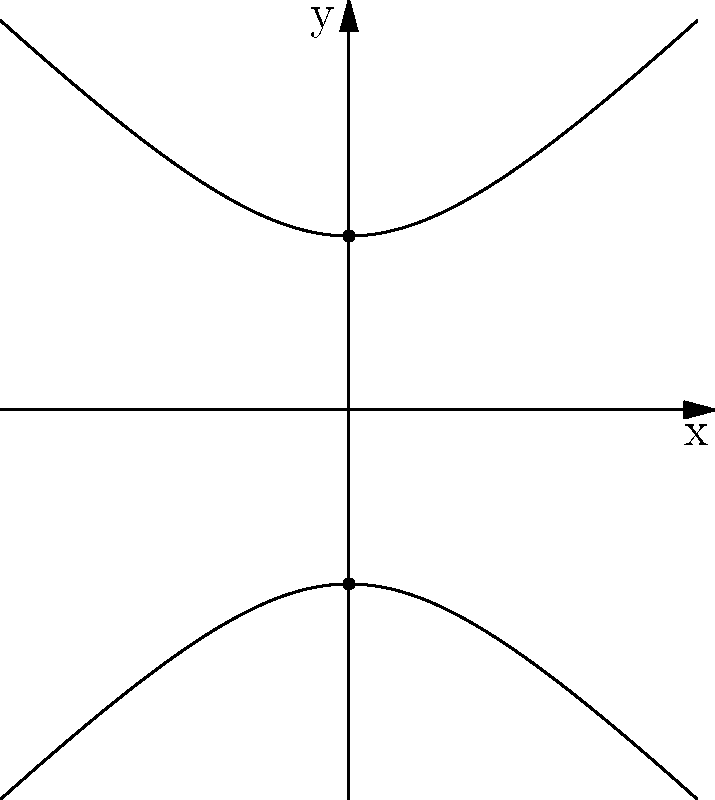As part of a stress management module in your online course, you're discussing how visualizing geometric shapes can aid in relaxation. Identify the type of conic section represented by the graph above and explain its significance in promoting calmness. To identify the conic section and relate it to stress management, let's follow these steps:

1. Observe the shape: The graph shows two curved lines that are symmetrical about the x-axis and extend infinitely in both directions.

2. Identify key features:
   - The curves never intersect the x-axis
   - The curves have two distinct parts (upper and lower)
   - The shape appears to have two focal points (vertices) at (0,1) and (0,-1)

3. Recognize the conic section: Based on these characteristics, this graph represents a hyperbola.

4. Mathematical representation: The standard form of a hyperbola centered at the origin with vertices at (0,a) and (0,-a) is:

   $$\frac{y^2}{a^2} - \frac{x^2}{b^2} = 1$$

   In this case, $a=1$ and $b=1$, so the equation is:

   $$y^2 - x^2 = 1$$

5. Relation to stress management:
   - The hyperbola's smooth, symmetrical shape can be visually calming
   - Its infinite nature can represent the idea of limitless possibilities or growth
   - The two separate curves can symbolize balance or duality in life
   - Focusing on tracing the curves mentally can serve as a meditation exercise

By incorporating this geometric visualization into relaxation techniques, students can use the hyperbola as a focal point for mindfulness exercises, promoting calmness and reducing stress.
Answer: Hyperbola; promotes calmness through symmetry, infinity concept, and visual meditation. 